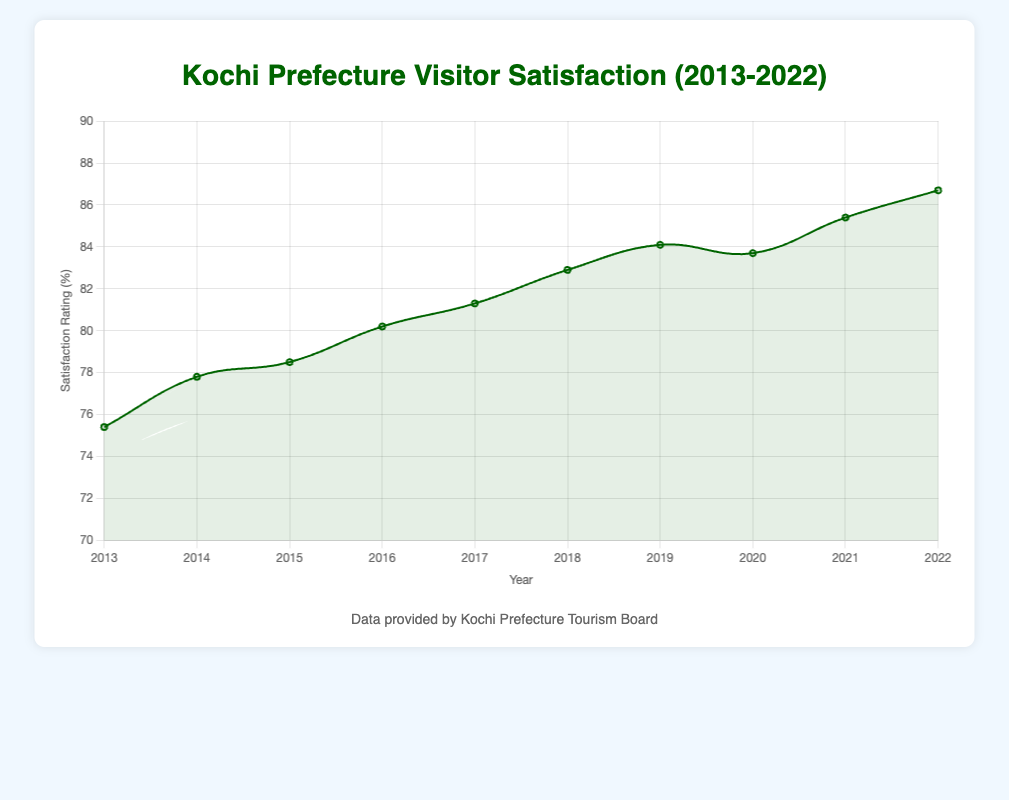What is the overall trend of the visitor satisfaction ratings from 2013 to 2022? The overall trend can be observed by looking at the direction of the line from 2013 to 2022. The line shows an upward trend, indicating increasing satisfaction ratings over the years.
Answer: Increasing In which year did Kochi Prefecture witness the highest visitor satisfaction rating? To find the year with the highest visitor satisfaction rating, look for the peak value on the plot. The highest satisfaction rating is 86.7% in the year 2022.
Answer: 2022 What is the average visitor satisfaction rating from 2013 to 2022? Calculate the average by adding all the satisfaction ratings for each year and dividing by the number of years: (75.4 + 77.8 + 78.5 + 80.2 + 81.3 + 82.9 + 84.1 + 83.7 + 85.4 + 86.7) / 10 = 81.6.
Answer: 81.6 Which year saw the biggest increase in visitor satisfaction from the previous year? Calculate the yearly differences and identify the largest one: 2014 - 2013 = 2.4, 2015 - 2014 = 0.7, 2016 - 2015 = 1.7, 2017 - 2016 = 1.1, 2018 - 2017 = 1.6, 2019 - 2018 = 1.2, 2020 - 2019 = -0.4, 2021 - 2020 = 1.7, 2022 - 2021 = 1.3. The largest increase is 2.4 in the year 2014.
Answer: 2014 How did visitor satisfaction change between 2019 and 2020, and what might you infer from the notable sites listed for these years? The visitor satisfaction slightly decreased from 84.1% in 2019 to 83.7% in 2020. The notable sites remained the same in these years, suggesting other factors might have influenced the ratings such as external circumstances or visitor experiences.
Answer: Decreased by 0.4% Which year showed the smallest difference in visitor satisfaction compared to the previous year? Compare the differences between consecutive years and identify the smallest one: 2014 - 2013 = 2.4, 2015 - 2014 = 0.7, 2016 - 2015 = 1.7, 2017 - 2016 = 1.1, 2018 - 2017 = 1.6, 2019 - 2018 = 1.2, 2020 - 2019 = -0.4, 2021 - 2020 = 1.7, 2022 - 2021 = 1.3. The smallest difference is 0.7 between 2014 and 2015.
Answer: 2015 Compare the visitor satisfaction ratings of 2017 and 2019. What is the difference? Subtract the 2017 rating from the 2019 rating: 84.1 - 81.3 = 2.8. The visitor satisfaction increased by 2.8%.
Answer: 2.8% Describe the visual trend of the plot's curve from the year 2013 to 2022. The curve starts at 75.4% in 2013 and shows a consistent upward trend with minor fluctuations, peaking at 86.7% in 2022. This indicates overall improved visitor satisfaction over the years.
Answer: Upward Trend 